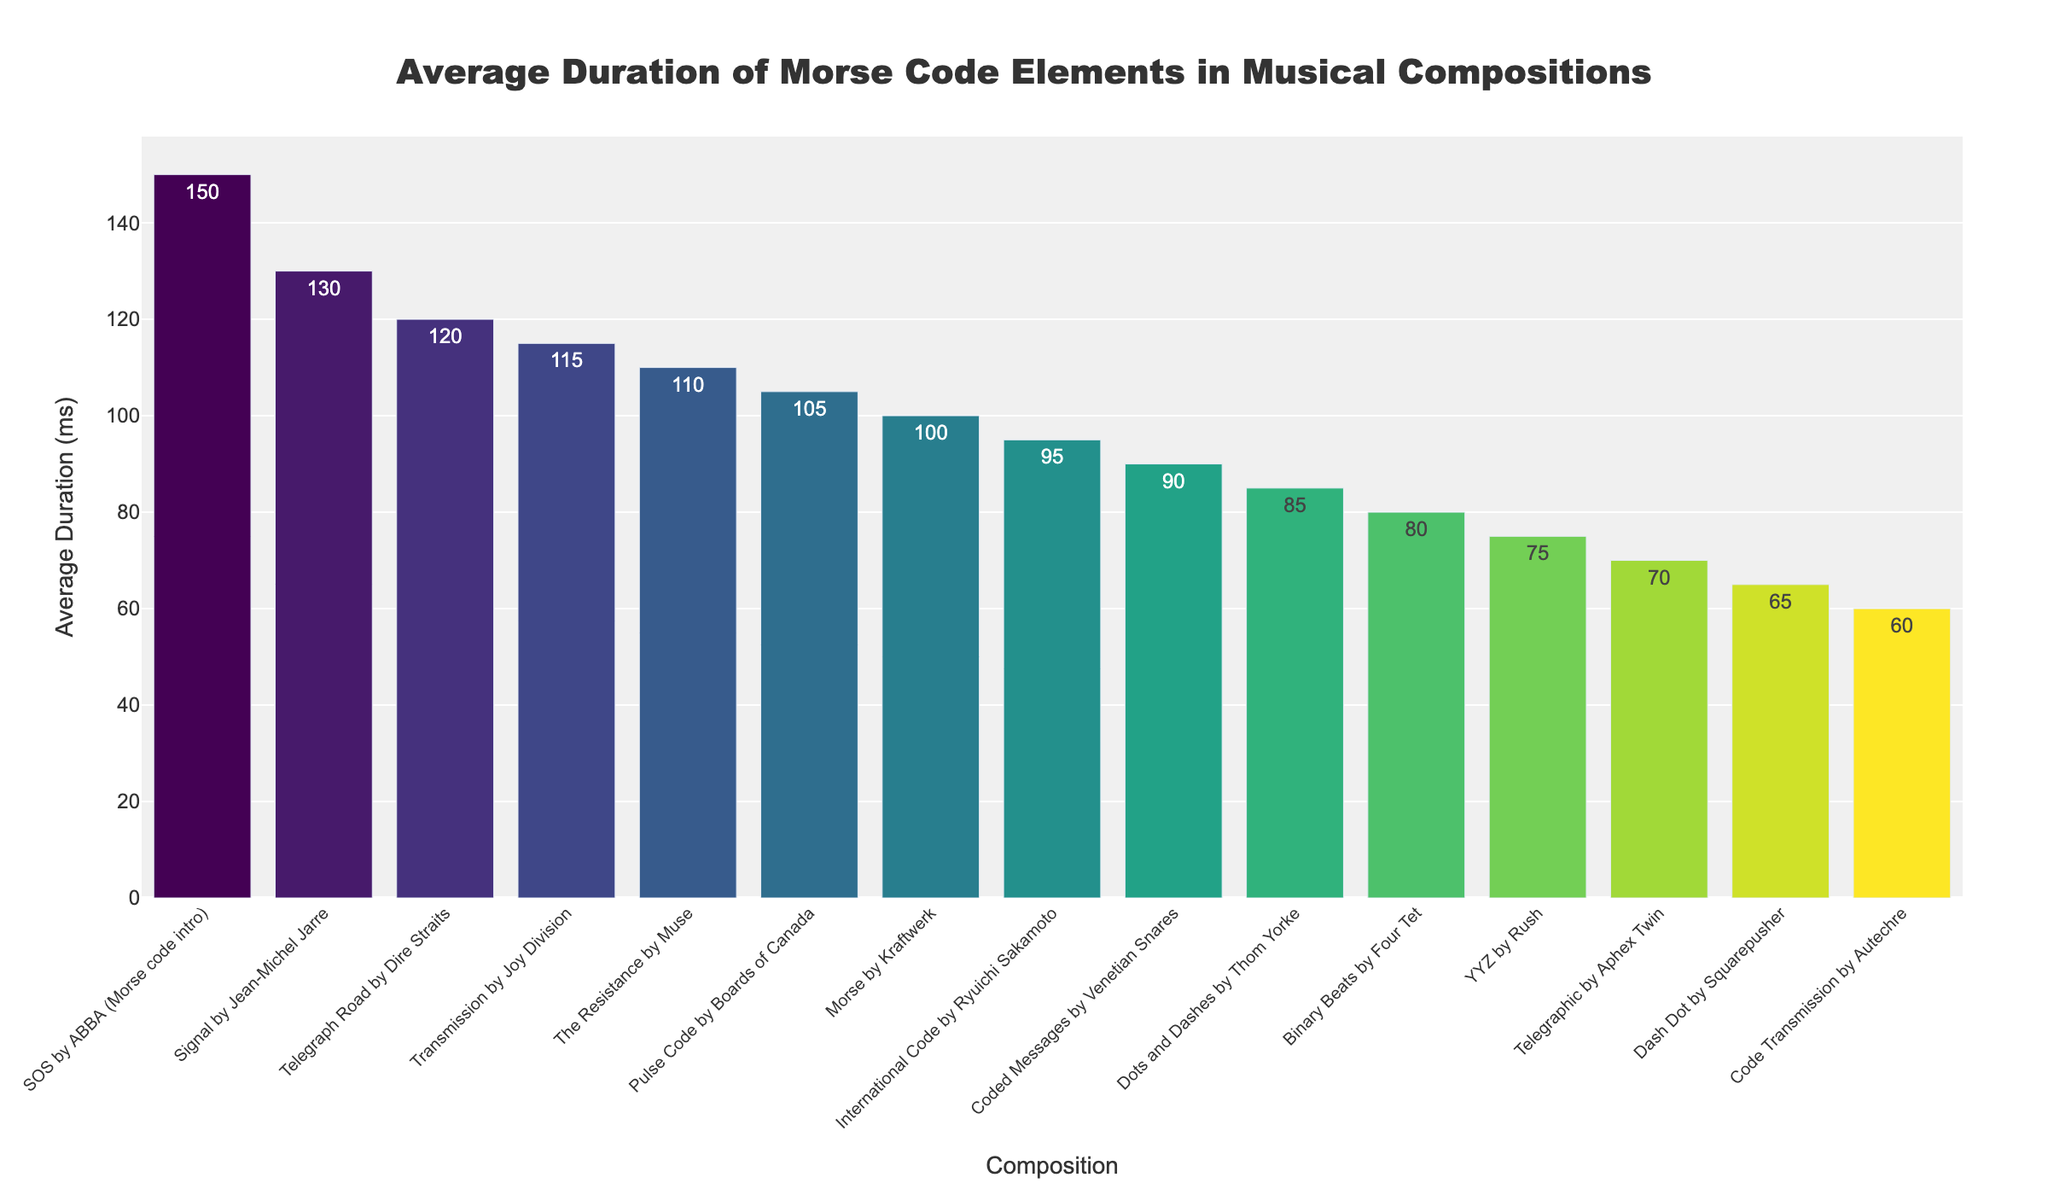What's the composition with the longest average duration of Morse code elements? The bar chart shows the musical compositions sorted by the average duration of Morse code elements in descending order. The first bar (at the top of the chart) represents the longest average duration.
Answer: "SOS" by ABBA (Morse code intro) Which compositions have an average duration of Morse code elements greater than 100 ms? By inspecting the bars in the chart, compositions with bars extending beyond the 100 ms mark on the y-axis are listed.
Answer: "SOS" by ABBA (Morse code intro), "Signal" by Jean-Michel Jarre, "Telegraph Road" by Dire Straits, "Transmission" by Joy Division, "The Resistance" by Muse, "Pulse Code" by Boards of Canada, "Morse" by Kraftwerk Which composition has a shorter average duration of Morse code elements, "YYZ" by Rush or "International Code" by Ryuichi Sakamoto? By comparing the height of the bars for "YYZ" by Rush and "International Code" by Ryuichi Sakamoto, the one with the shorter bar has the shorter average duration.
Answer: "YYZ" by Rush What's the total average duration if we sum the average durations of the top three longest compositions? The top three compositions sorted by average duration are: 150 ms for "SOS" by ABBA, 130 ms for "Signal" by Jean-Michel Jarre, and 120 ms for "Telegraph Road" by Dire Straits. Summing these gives 150 + 130 + 120 = 400 ms.
Answer: 400 ms What's the average duration of the composition with the shortest Morse code elements? The bottom bar on the chart represents the composition with the shortest average duration.
Answer: "Code Transmission" by Autechre (60 ms) How many compositions have an average duration of Morse code elements between 80 ms and 100 ms? By looking at the bar chart, count the bars whose y-values fall between the 80 ms and 100 ms marks on the y-axis.
Answer: Five compositions: "Binary Beats" by Four Tet, "Dots and Dashes" by Thom Yorke, "International Code" by Ryuichi Sakamoto, "Coded Messages" by Venetian Snares, "YYZ" by Rush Which composition has an average duration closest to 95 ms? Inspect the bars near the 95 ms mark on the y-axis to find the composition with the closest average duration.
Answer: "International Code" by Ryuichi Sakamoto (95 ms) What's the difference in average duration of Morse code elements between the compositions "Dots and Dashes" by Thom Yorke and "Pulse Code" by Boards of Canada? Subtract the average duration of "Dots and Dashes" by Thom Yorke (85 ms) from the average duration of "Pulse Code" by Boards of Canada (105 ms): 105 - 85 = 20 ms.
Answer: 20 ms 